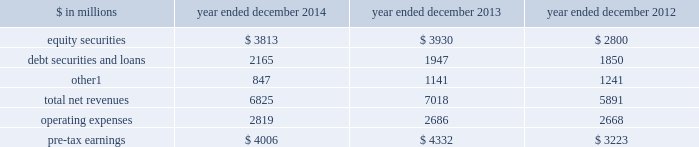Management 2019s discussion and analysis investing & lending investing & lending includes our investing activities and the origination of loans to provide financing to clients .
These investments and loans are typically longer-term in nature .
We make investments , some of which are consolidated , directly and indirectly through funds that we manage , in debt securities and loans , public and private equity securities , and real estate entities .
The table below presents the operating results of our investing & lending segment. .
Includes net revenues of $ 325 million for 2014 , $ 329 million for 2013 and $ 362 million for 2012 related to metro international trade services llc .
We completed the sale of this consolidated investment in december 2014 .
2014 versus 2013 .
Net revenues in investing & lending were $ 6.83 billion for 2014 , 3% ( 3 % ) lower than 2013 .
Net gains from investments in equity securities were slightly lower due to a significant decrease in net gains from investments in public equities , as movements in global equity prices during 2014 were less favorable compared with 2013 , partially offset by an increase in net gains from investments in private equities , primarily driven by company-specific events .
Net revenues from debt securities and loans were higher than 2013 , reflecting a significant increase in net interest income , primarily driven by increased lending , and a slight increase in net gains , primarily due to sales of certain investments during 2014 .
Other net revenues , related to our consolidated investments , were significantly lower compared with 2013 , reflecting a decrease in operating revenues from commodities-related consolidated investments .
During 2014 , net revenues in investing & lending generally reflected favorable company-specific events , including initial public offerings and financings , and strong corporate performance , as well as net gains from sales of certain investments .
However , concerns about the outlook for the global economy and uncertainty over the impact of financial regulatory reform continue to be meaningful considerations for the global marketplace .
If equity markets decline or credit spreads widen , net revenues in investing & lending would likely be negatively impacted .
Operating expenses were $ 2.82 billion for 2014 , 5% ( 5 % ) higher than 2013 , reflecting higher compensation and benefits expenses , partially offset by lower expenses related to consolidated investments .
Pre-tax earnings were $ 4.01 billion in 2014 , 8% ( 8 % ) lower than 2013 .
2013 versus 2012 .
Net revenues in investing & lending were $ 7.02 billion for 2013 , 19% ( 19 % ) higher than 2012 , reflecting a significant increase in net gains from investments in equity securities , driven by company-specific events and stronger corporate performance , as well as significantly higher global equity prices .
In addition , net gains and net interest income from debt securities and loans were slightly higher , while other net revenues , related to our consolidated investments , were lower compared with 2012 .
During 2013 , net revenues in investing & lending generally reflected favorable company-specific events and strong corporate performance , as well as the impact of significantly higher global equity prices and tighter corporate credit spreads .
Operating expenses were $ 2.69 billion for 2013 , essentially unchanged compared with 2012 .
Operating expenses during 2013 included lower impairment charges and lower operating expenses related to consolidated investments , partially offset by increased compensation and benefits expenses due to higher net revenues compared with 2012 .
Pre-tax earnings were $ 4.33 billion in 2013 , 34% ( 34 % ) higher than 2012 .
Goldman sachs 2014 annual report 45 .
In millions for 2014 2013 and 2012 , what was the total balance of debt securities and loans?\\n? 
Computations: table_sum(debt securities and loans, none)
Answer: 5962.0. 